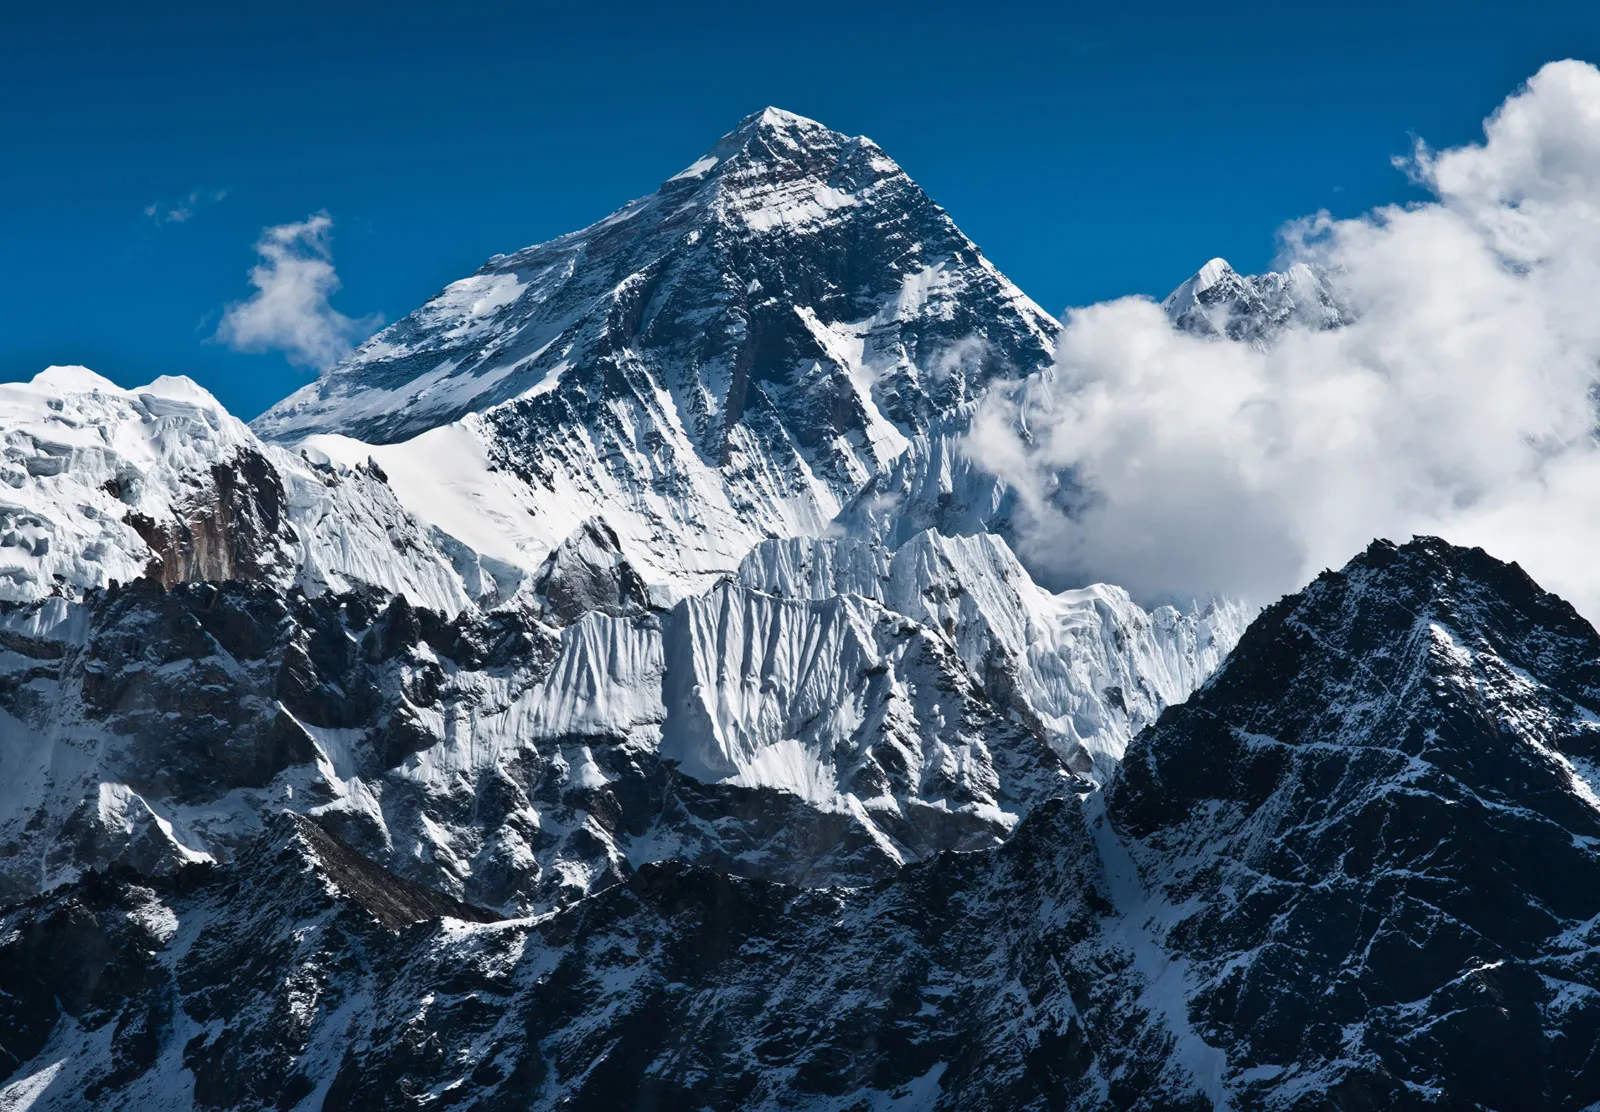Can you describe a story inspired by this image of Mount Everest? Once upon a time, in the shadow of Mount Everest, a young sherpa named Tenzin set out on an incredible journey. Raised in a small village nestled among the Himalayan foothills, Tenzin had always been captivated by tales of the legendary mountain. He dreamt of one day reaching its summit, not only to honor his ancestors but also to experience the ultimate sense of accomplishment and connection to the natural world. Gathering the support of his community and with a heart full of courage, he embarked on a climb that would push him to the limits of his endurance and determination. 